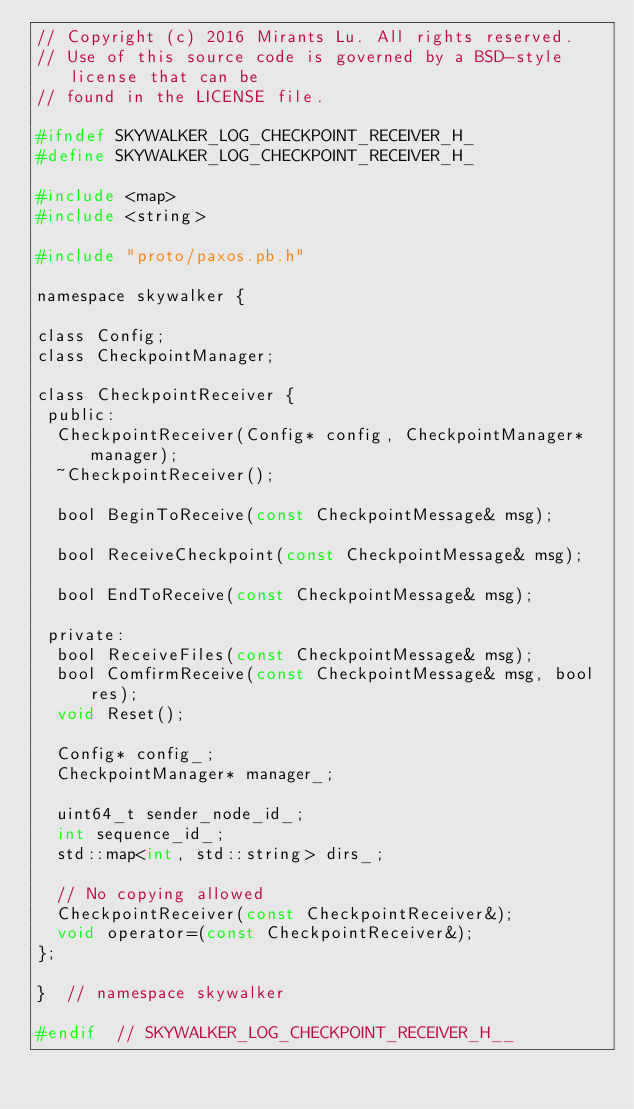<code> <loc_0><loc_0><loc_500><loc_500><_C_>// Copyright (c) 2016 Mirants Lu. All rights reserved.
// Use of this source code is governed by a BSD-style license that can be
// found in the LICENSE file.

#ifndef SKYWALKER_LOG_CHECKPOINT_RECEIVER_H_
#define SKYWALKER_LOG_CHECKPOINT_RECEIVER_H_

#include <map>
#include <string>

#include "proto/paxos.pb.h"

namespace skywalker {

class Config;
class CheckpointManager;

class CheckpointReceiver {
 public:
  CheckpointReceiver(Config* config, CheckpointManager* manager);
  ~CheckpointReceiver();

  bool BeginToReceive(const CheckpointMessage& msg);

  bool ReceiveCheckpoint(const CheckpointMessage& msg);

  bool EndToReceive(const CheckpointMessage& msg);

 private:
  bool ReceiveFiles(const CheckpointMessage& msg);
  bool ComfirmReceive(const CheckpointMessage& msg, bool res);
  void Reset();

  Config* config_;
  CheckpointManager* manager_;

  uint64_t sender_node_id_;
  int sequence_id_;
  std::map<int, std::string> dirs_;

  // No copying allowed
  CheckpointReceiver(const CheckpointReceiver&);
  void operator=(const CheckpointReceiver&);
};

}  // namespace skywalker

#endif  // SKYWALKER_LOG_CHECKPOINT_RECEIVER_H__
</code> 